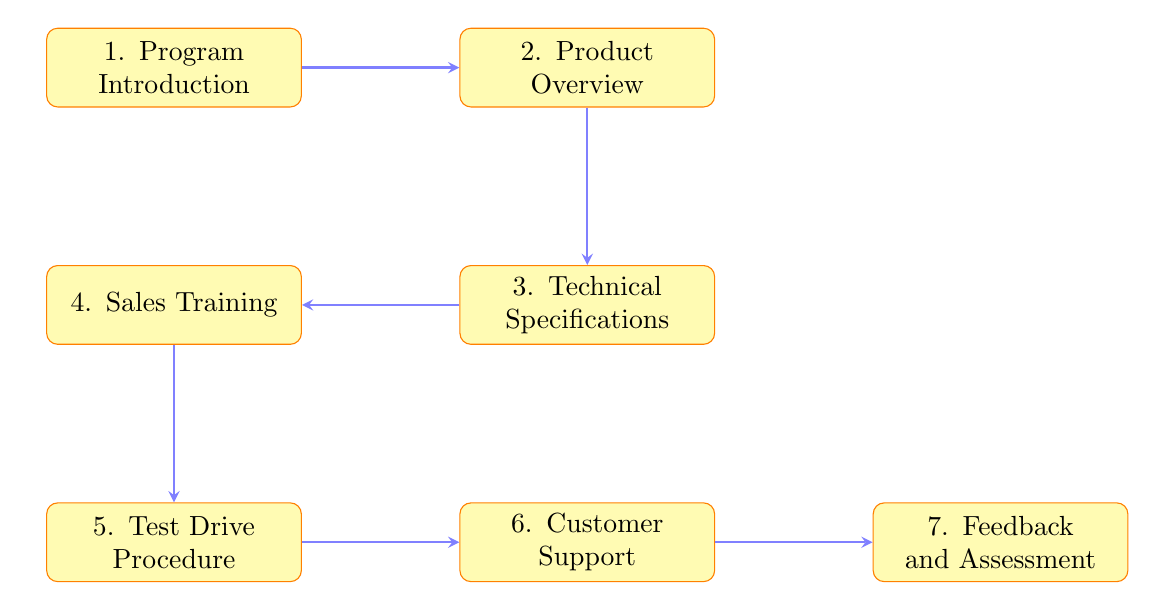What is the first step in the training program? The first step, as shown in the diagram, is "Program Introduction". It is the starting point of the training program for new van models.
Answer: Program Introduction How many total steps are included in the dealer training program? The diagram shows a total of seven steps, from "Program Introduction" to "Feedback and Assessment." Each step is represented by a process node.
Answer: Seven What step comes after "Technical Specifications"? According to the flow of the diagram, "Sales Training" follows "Technical Specifications," indicating the sequence of the training program.
Answer: Sales Training What is the last step of the training program? The last step in the diagram is "Feedback and Assessment," which follows the "Customer Support" step, marking the endpoint of the training process.
Answer: Feedback and Assessment Which step involves customer test drives? "Test Drive Procedure" is the step dedicated to organizing and conducting customer test drives, as indicated in the flow chart.
Answer: Test Drive Procedure What are the two steps that directly follow "Sales Training"? The "Test Drive Procedure" follows "Sales Training" directly, and subsequently, "Customer Support" follows the "Test Drive Procedure." This shows the progression from selling to supporting the customers.
Answer: Test Drive Procedure, Customer Support How do "Customer Support" and "Feedback and Assessment" relate in the flow? "Customer Support" leads directly into "Feedback and Assessment," indicating that after providing support, there is a process of collecting feedback and assessing dealer performance as a continuation.
Answer: Directly leads to What is the focus of the "Customer Support" step? The focus of "Customer Support" is on training the dealers to provide post-sales support and services to customers, highlighted in the description within the framework.
Answer: Post-sales support and services 